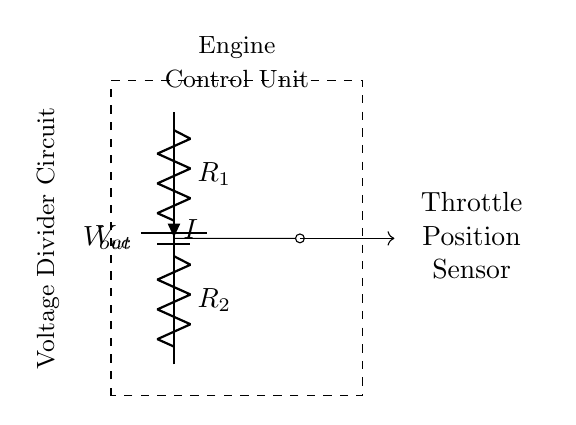What is the role of the throttle position sensor? The throttle position sensor measures the position of the throttle valve in the engine, indicating how much air enters the engine. This information is crucial for controlling fuel injection and ignition timing.
Answer: Throttle position measurement What is the function of resistors in this circuit? The resistors create a voltage divider, reducing the input voltage to a value that can be used by the throttle position sensor. The voltage across resistor R2 is the output voltage supplied to the sensor.
Answer: Voltage divider What is the output voltage direction in the circuit? The output voltage (Vout) is taken from the junction between the two resistors R1 and R2, directed toward the throttle position sensor.
Answer: Toward sensor How many resistors are used in this voltage divider? There are two resistors (R1 and R2) in the voltage divider circuit. The two resistors determine the scaling of the input voltage for the sensor.
Answer: Two What is the total voltage supply in the circuit? The total voltage supply in the circuit is denoted as Vcc, which is typically the battery voltage of the vehicle. The exact value would depend on the specific vehicle but is commonly 12 volts.
Answer: Vcc What happens to output voltage if R2 increases? If R2 increases, the output voltage (Vout) will increase as well, since a larger resistor in the lower position of the voltage divider increases the fraction of Vcc seen at the output.
Answer: Increases How does the voltage divider affect the throttle position sensor's function? The voltage divider provides a scaled-down version of the supply voltage to the throttle position sensor, allowing it to accurately sense the throttle opening without exceeding its input voltage limits.
Answer: Scaled voltage for sensor 